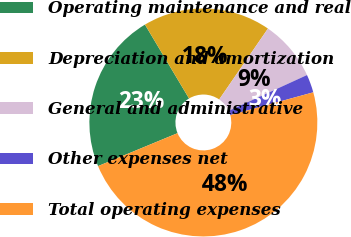Convert chart. <chart><loc_0><loc_0><loc_500><loc_500><pie_chart><fcel>Operating maintenance and real<fcel>Depreciation and amortization<fcel>General and administrative<fcel>Other expenses net<fcel>Total operating expenses<nl><fcel>22.69%<fcel>18.15%<fcel>8.58%<fcel>2.57%<fcel>48.01%<nl></chart> 